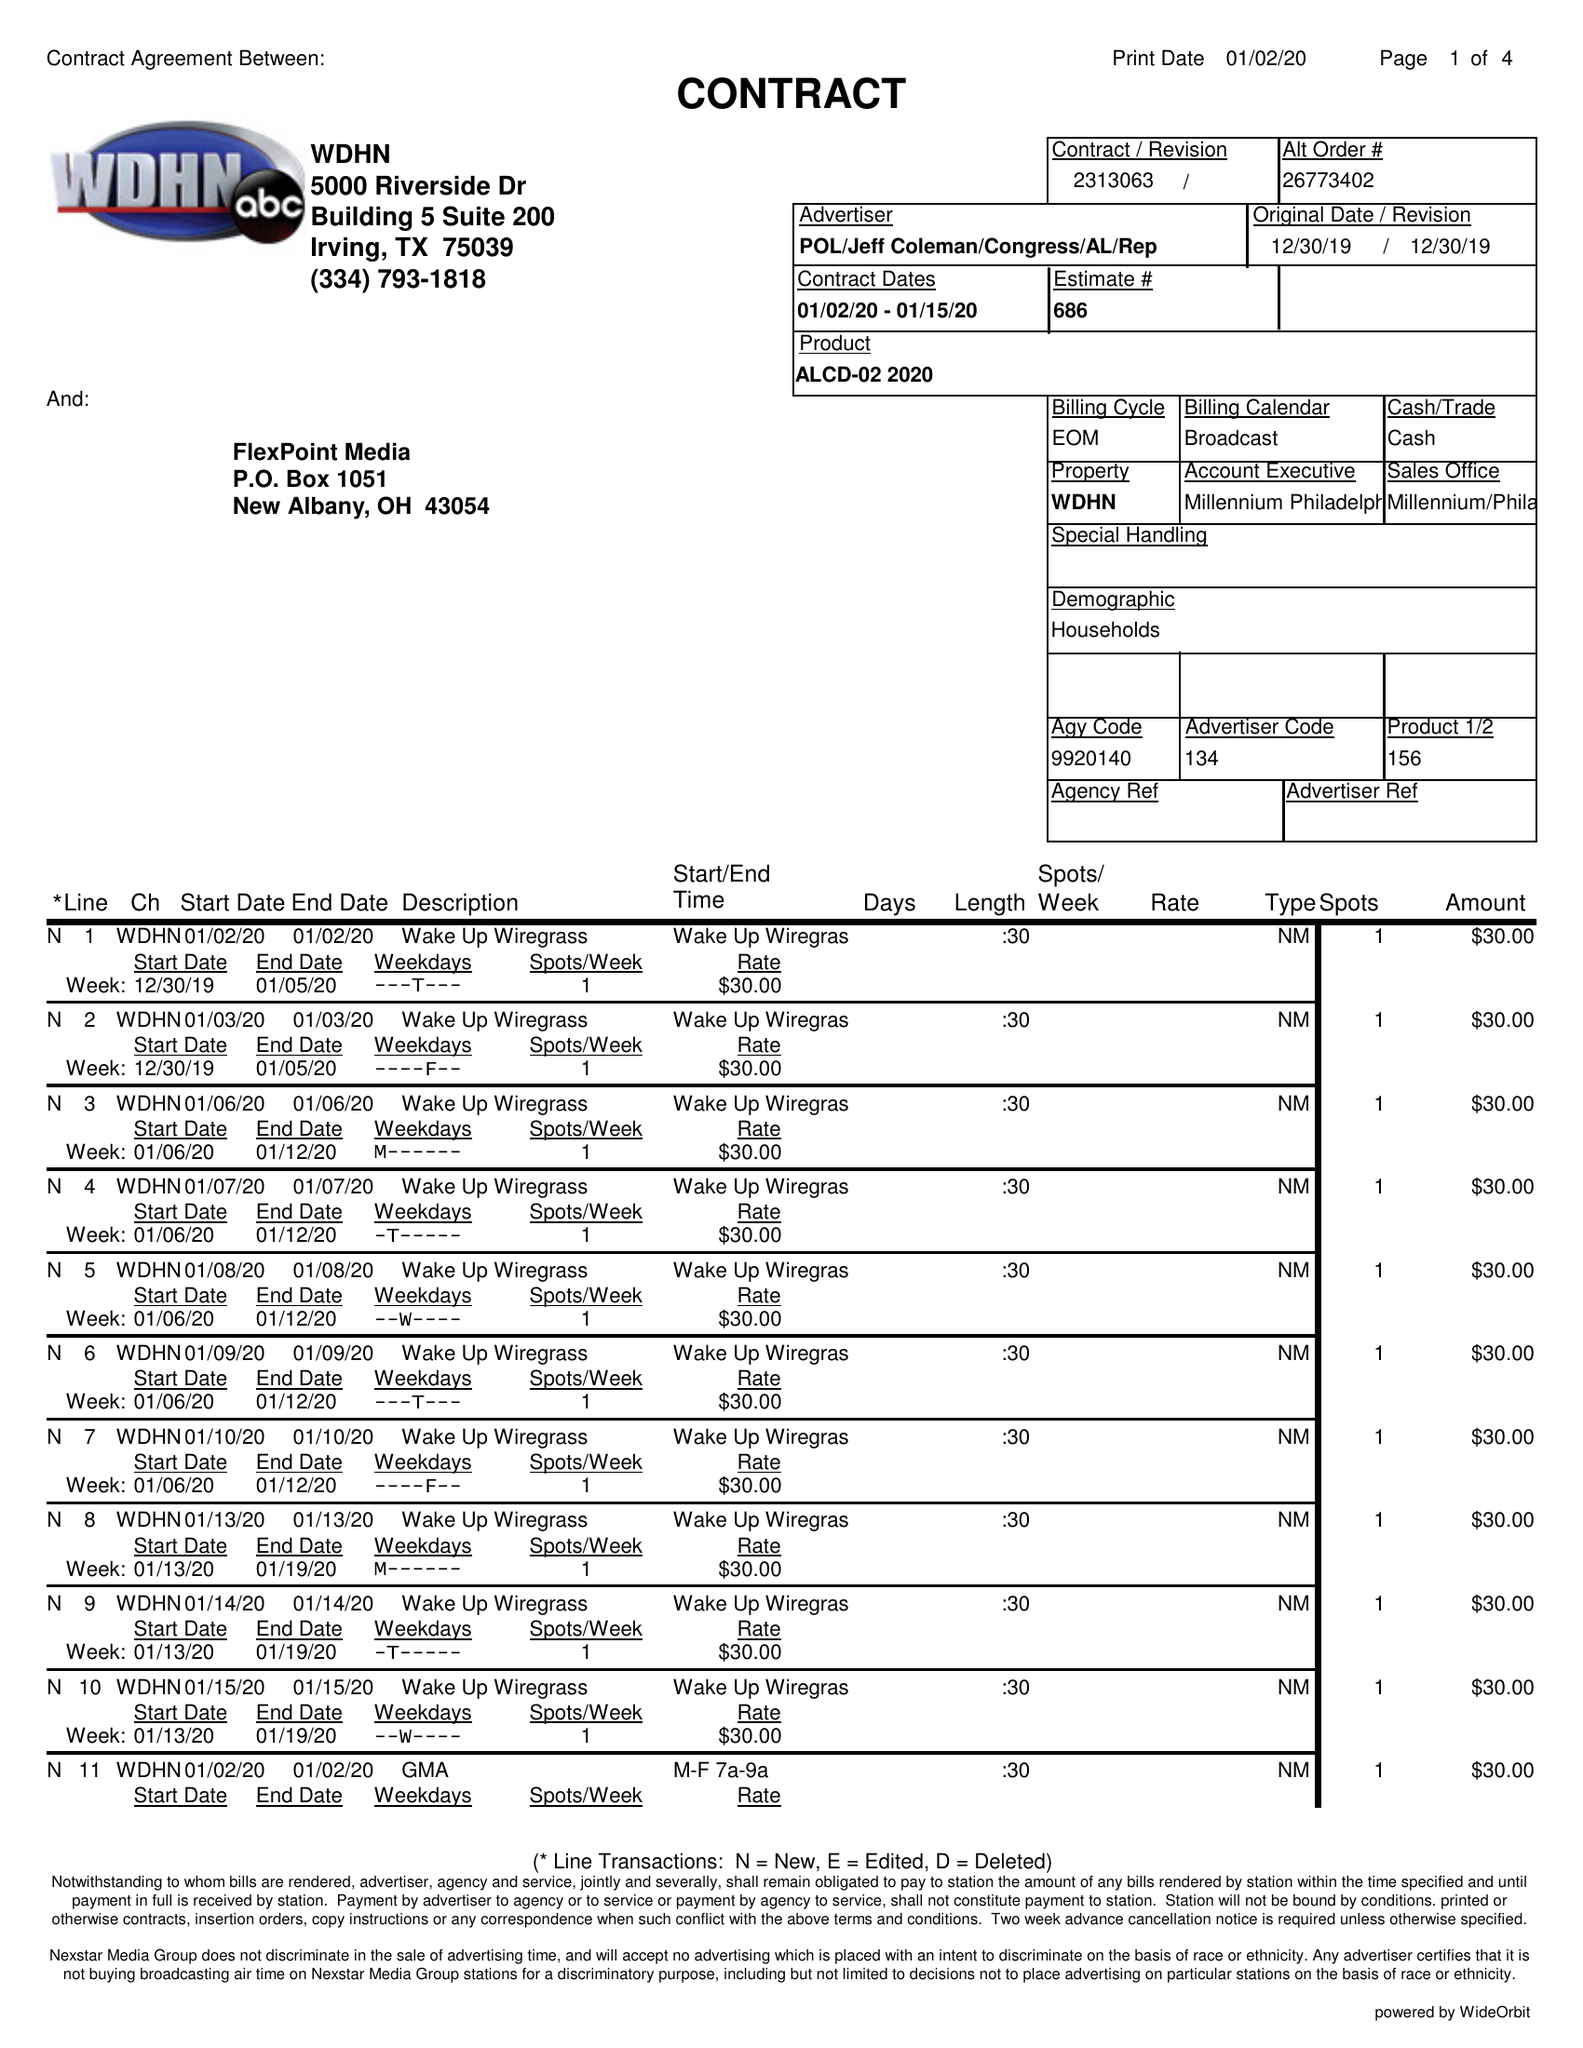What is the value for the flight_to?
Answer the question using a single word or phrase. 01/15/20 